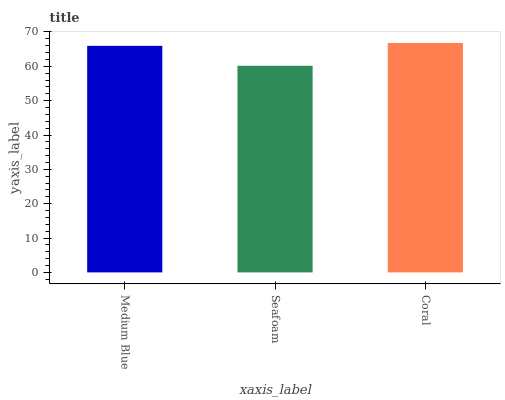Is Seafoam the minimum?
Answer yes or no. Yes. Is Coral the maximum?
Answer yes or no. Yes. Is Coral the minimum?
Answer yes or no. No. Is Seafoam the maximum?
Answer yes or no. No. Is Coral greater than Seafoam?
Answer yes or no. Yes. Is Seafoam less than Coral?
Answer yes or no. Yes. Is Seafoam greater than Coral?
Answer yes or no. No. Is Coral less than Seafoam?
Answer yes or no. No. Is Medium Blue the high median?
Answer yes or no. Yes. Is Medium Blue the low median?
Answer yes or no. Yes. Is Coral the high median?
Answer yes or no. No. Is Seafoam the low median?
Answer yes or no. No. 